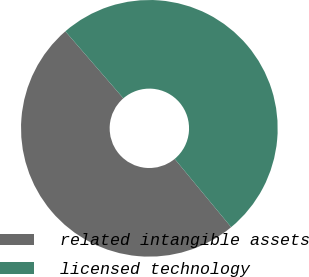Convert chart to OTSL. <chart><loc_0><loc_0><loc_500><loc_500><pie_chart><fcel>related intangible assets<fcel>licensed technology<nl><fcel>49.64%<fcel>50.36%<nl></chart> 